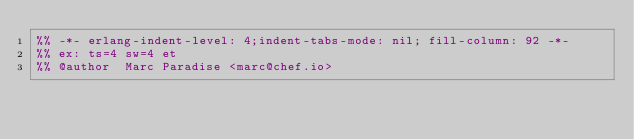<code> <loc_0><loc_0><loc_500><loc_500><_Erlang_>%% -*- erlang-indent-level: 4;indent-tabs-mode: nil; fill-column: 92 -*-
%% ex: ts=4 sw=4 et
%% @author  Marc Paradise <marc@chef.io></code> 